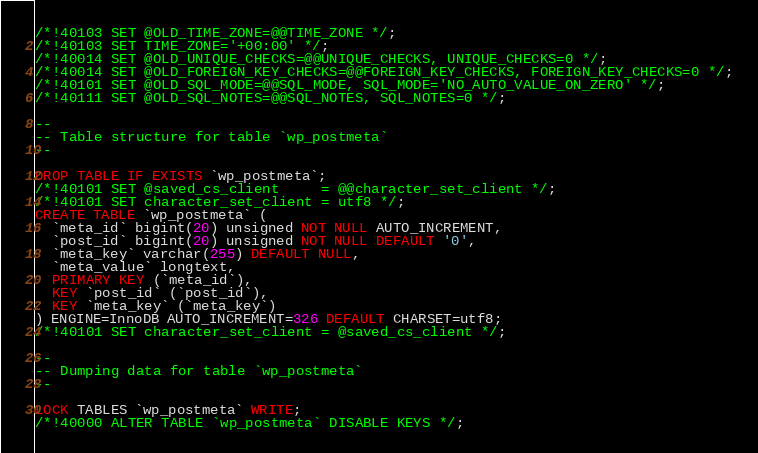<code> <loc_0><loc_0><loc_500><loc_500><_SQL_>/*!40103 SET @OLD_TIME_ZONE=@@TIME_ZONE */;
/*!40103 SET TIME_ZONE='+00:00' */;
/*!40014 SET @OLD_UNIQUE_CHECKS=@@UNIQUE_CHECKS, UNIQUE_CHECKS=0 */;
/*!40014 SET @OLD_FOREIGN_KEY_CHECKS=@@FOREIGN_KEY_CHECKS, FOREIGN_KEY_CHECKS=0 */;
/*!40101 SET @OLD_SQL_MODE=@@SQL_MODE, SQL_MODE='NO_AUTO_VALUE_ON_ZERO' */;
/*!40111 SET @OLD_SQL_NOTES=@@SQL_NOTES, SQL_NOTES=0 */;

--
-- Table structure for table `wp_postmeta`
--

DROP TABLE IF EXISTS `wp_postmeta`;
/*!40101 SET @saved_cs_client     = @@character_set_client */;
/*!40101 SET character_set_client = utf8 */;
CREATE TABLE `wp_postmeta` (
  `meta_id` bigint(20) unsigned NOT NULL AUTO_INCREMENT,
  `post_id` bigint(20) unsigned NOT NULL DEFAULT '0',
  `meta_key` varchar(255) DEFAULT NULL,
  `meta_value` longtext,
  PRIMARY KEY (`meta_id`),
  KEY `post_id` (`post_id`),
  KEY `meta_key` (`meta_key`)
) ENGINE=InnoDB AUTO_INCREMENT=326 DEFAULT CHARSET=utf8;
/*!40101 SET character_set_client = @saved_cs_client */;

--
-- Dumping data for table `wp_postmeta`
--

LOCK TABLES `wp_postmeta` WRITE;
/*!40000 ALTER TABLE `wp_postmeta` DISABLE KEYS */;</code> 